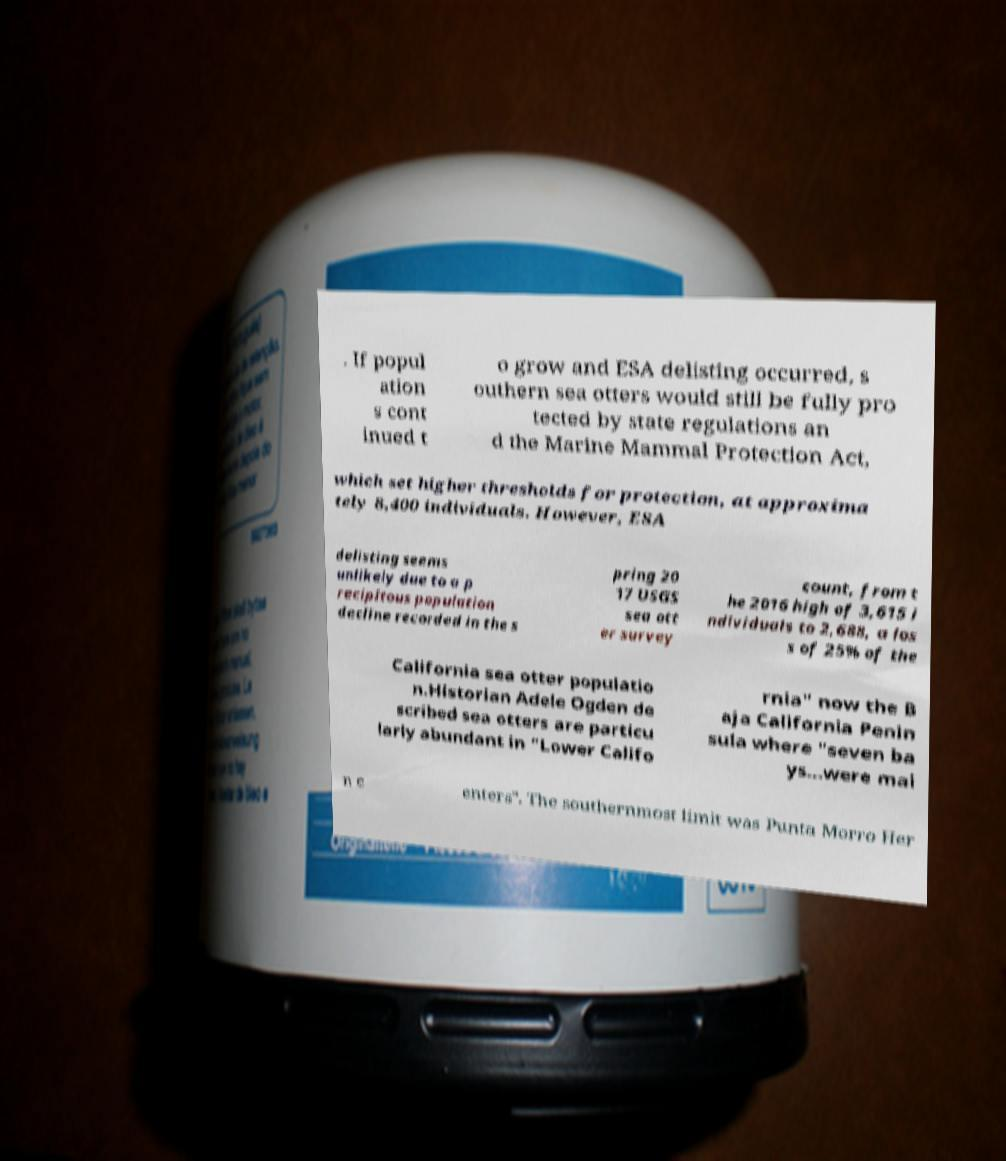I need the written content from this picture converted into text. Can you do that? . If popul ation s cont inued t o grow and ESA delisting occurred, s outhern sea otters would still be fully pro tected by state regulations an d the Marine Mammal Protection Act, which set higher thresholds for protection, at approxima tely 8,400 individuals. However, ESA delisting seems unlikely due to a p recipitous population decline recorded in the s pring 20 17 USGS sea ott er survey count, from t he 2016 high of 3,615 i ndividuals to 2,688, a los s of 25% of the California sea otter populatio n.Historian Adele Ogden de scribed sea otters are particu larly abundant in "Lower Califo rnia" now the B aja California Penin sula where "seven ba ys...were mai n c enters". The southernmost limit was Punta Morro Her 